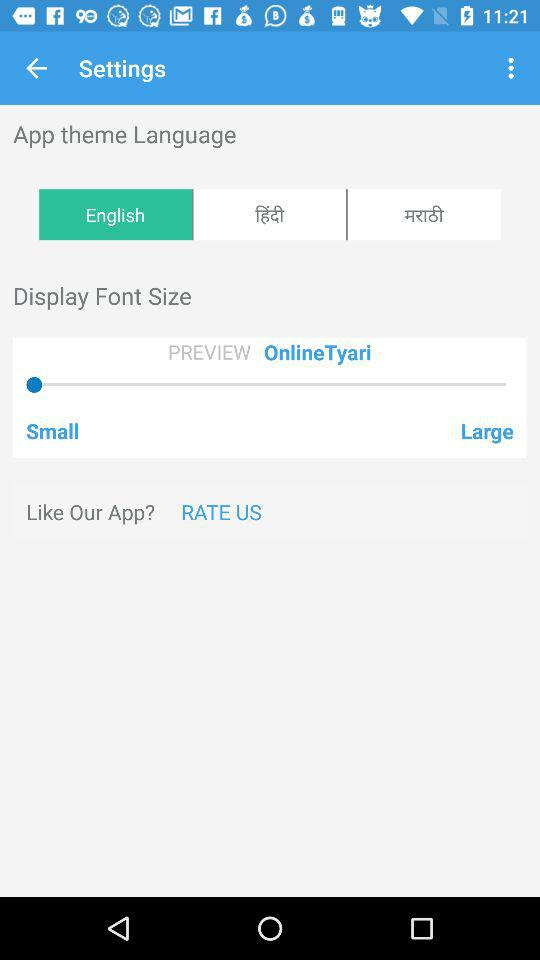Which is the selected theme language? The selected theme language is English. 